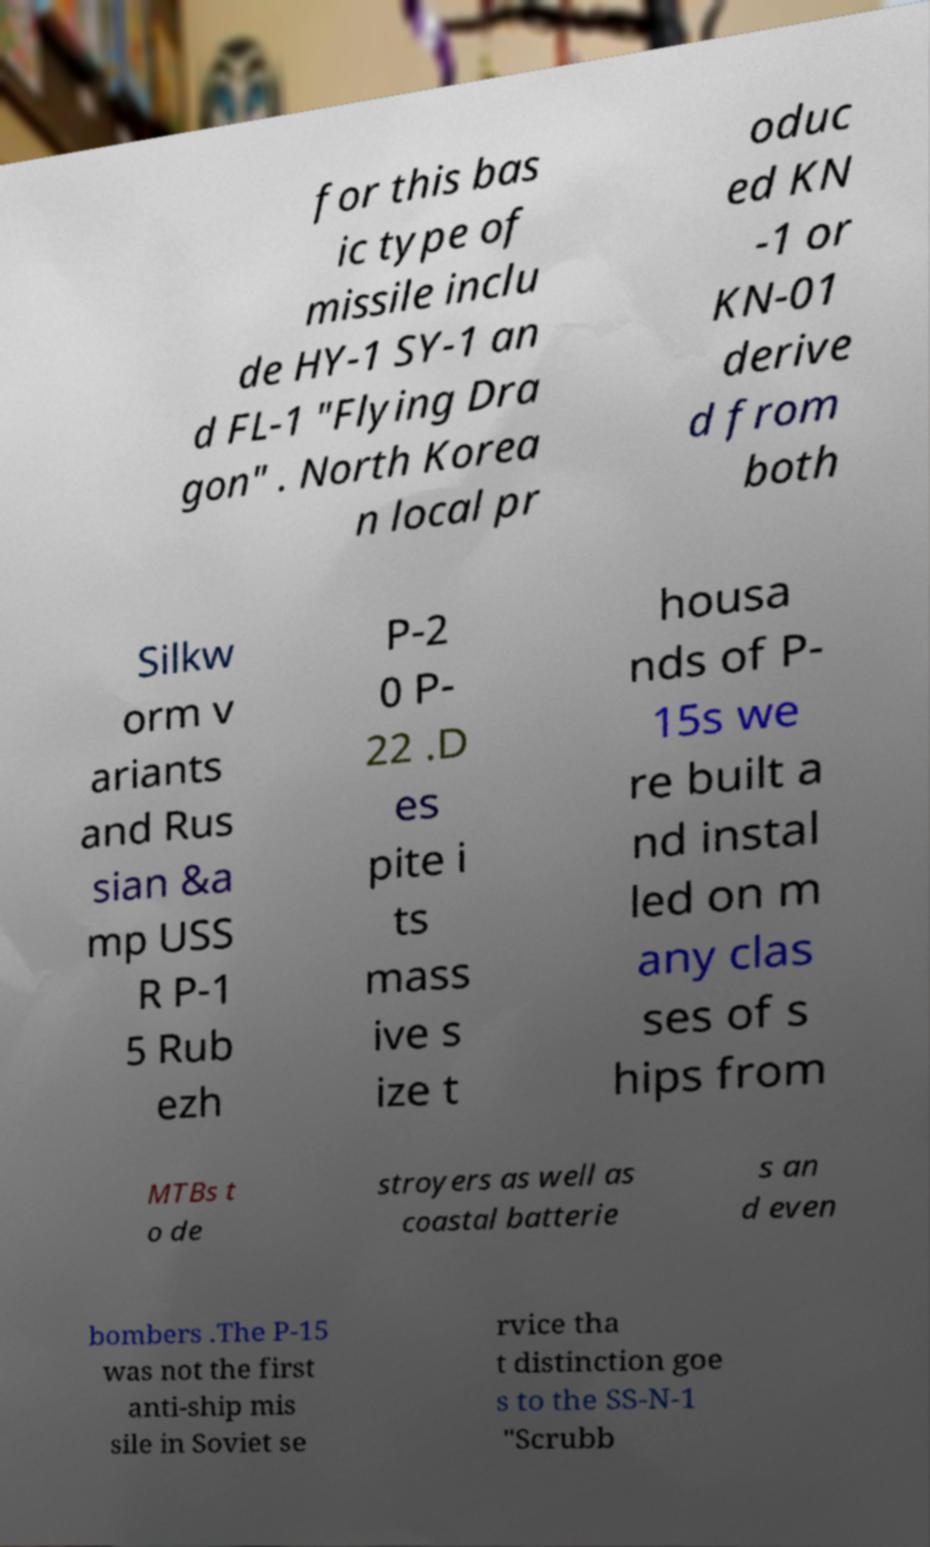For documentation purposes, I need the text within this image transcribed. Could you provide that? for this bas ic type of missile inclu de HY-1 SY-1 an d FL-1 "Flying Dra gon" . North Korea n local pr oduc ed KN -1 or KN-01 derive d from both Silkw orm v ariants and Rus sian &a mp USS R P-1 5 Rub ezh P-2 0 P- 22 .D es pite i ts mass ive s ize t housa nds of P- 15s we re built a nd instal led on m any clas ses of s hips from MTBs t o de stroyers as well as coastal batterie s an d even bombers .The P-15 was not the first anti-ship mis sile in Soviet se rvice tha t distinction goe s to the SS-N-1 "Scrubb 